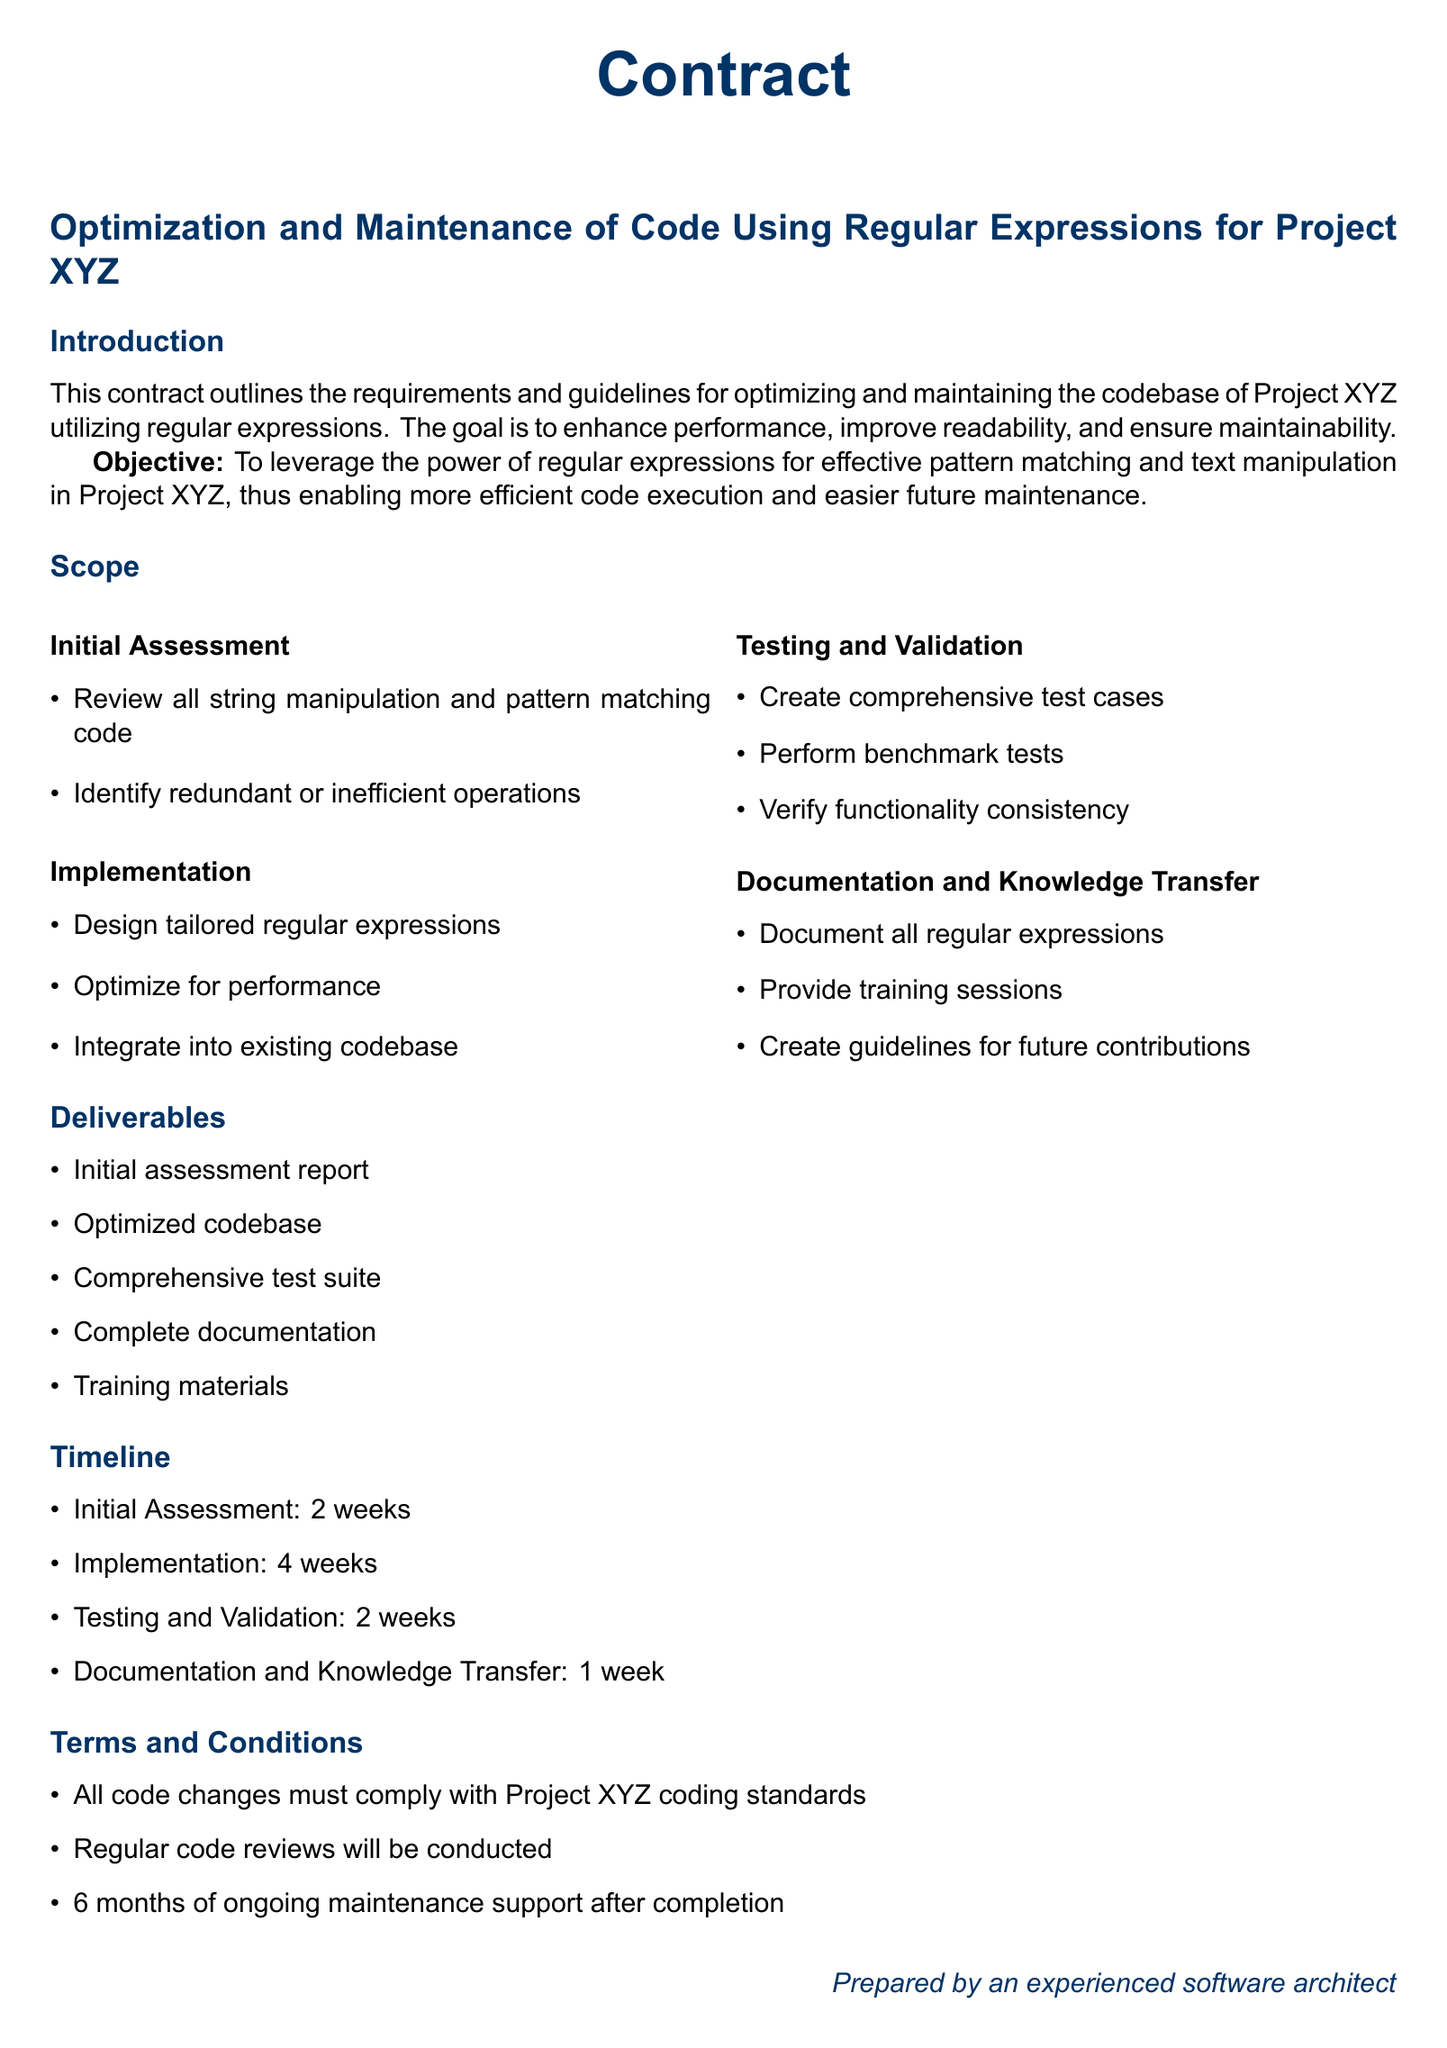What is the objective of the contract? The objective is to leverage the power of regular expressions for effective pattern matching and text manipulation in Project XYZ, thus enabling more efficient code execution and easier future maintenance.
Answer: To leverage the power of regular expressions How long is the initial assessment phase? The duration of the initial assessment phase is stated in the timeline section of the document.
Answer: 2 weeks What is one of the deliverables listed in the contract? The contract specifies several deliverables; one example is provided in the deliverables section.
Answer: Optimized codebase What will be created to ensure the functionality after optimization? The document mentions that comprehensive test cases will be created as part of the testing and validation process.
Answer: Comprehensive test cases How many weeks are dedicated to testing and validation? The timeline section indicates the amount of time allocated for this phase.
Answer: 2 weeks What type of support is mentioned after completion? The terms and conditions state that there will be ongoing support after the project completion.
Answer: 6 months of ongoing maintenance support What will be included in the documentation deliverables? The documentation will include all regular expressions, which is explicitly stated in the documentation and knowledge transfer section.
Answer: All regular expressions What is the primary focus of the document? The document focuses on the guidelines for optimizing and maintaining code using regular expressions for a specific project.
Answer: Optimization and Maintenance of Code Using Regular Expressions 